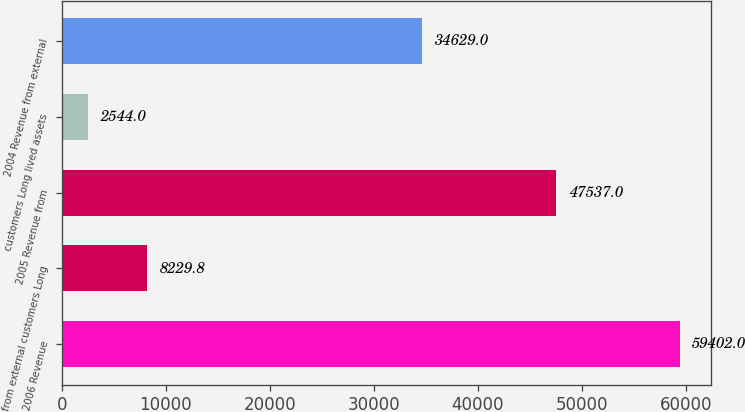Convert chart. <chart><loc_0><loc_0><loc_500><loc_500><bar_chart><fcel>2006 Revenue<fcel>from external customers Long<fcel>2005 Revenue from<fcel>customers Long lived assets<fcel>2004 Revenue from external<nl><fcel>59402<fcel>8229.8<fcel>47537<fcel>2544<fcel>34629<nl></chart> 